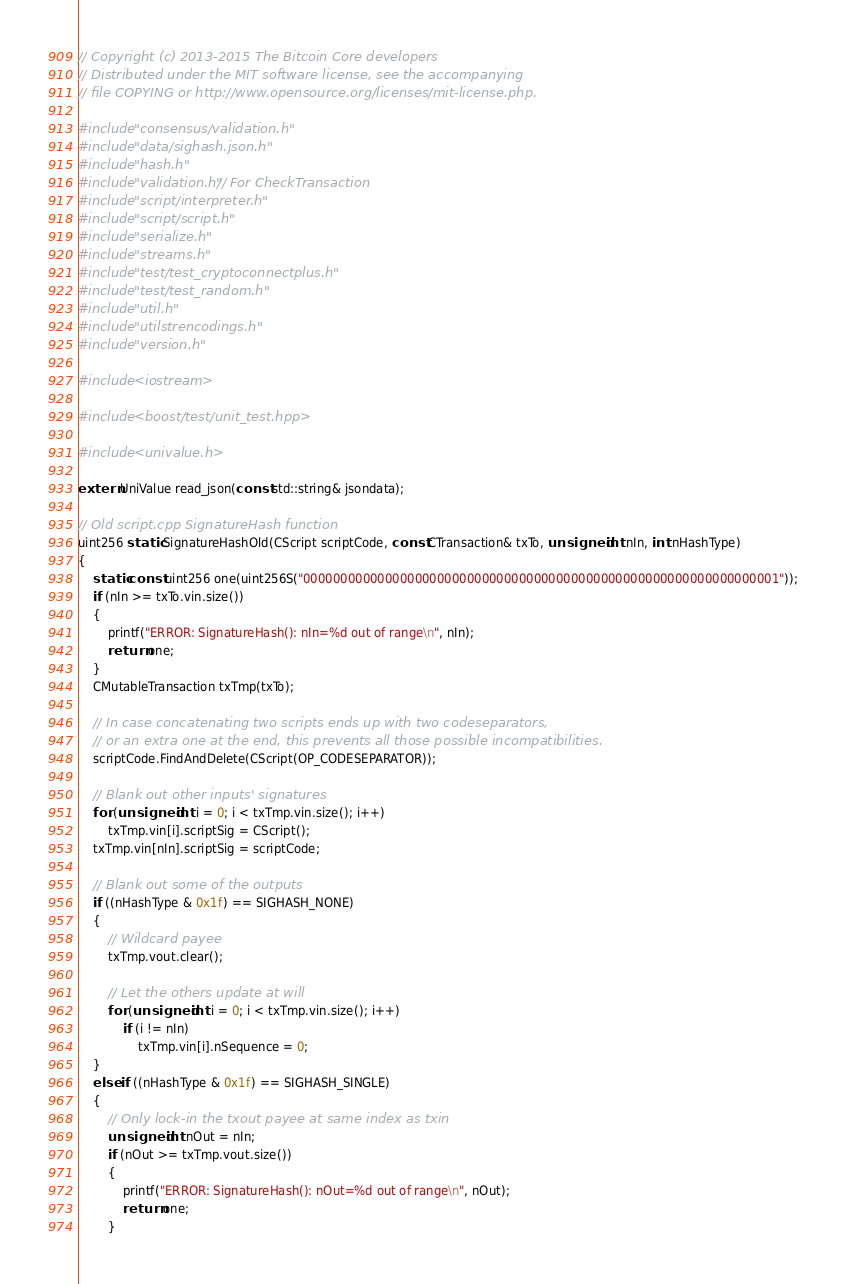Convert code to text. <code><loc_0><loc_0><loc_500><loc_500><_C++_>// Copyright (c) 2013-2015 The Bitcoin Core developers
// Distributed under the MIT software license, see the accompanying
// file COPYING or http://www.opensource.org/licenses/mit-license.php.

#include "consensus/validation.h"
#include "data/sighash.json.h"
#include "hash.h"
#include "validation.h" // For CheckTransaction
#include "script/interpreter.h"
#include "script/script.h"
#include "serialize.h"
#include "streams.h"
#include "test/test_cryptoconnectplus.h"
#include "test/test_random.h"
#include "util.h"
#include "utilstrencodings.h"
#include "version.h"

#include <iostream>

#include <boost/test/unit_test.hpp>

#include <univalue.h>

extern UniValue read_json(const std::string& jsondata);

// Old script.cpp SignatureHash function
uint256 static SignatureHashOld(CScript scriptCode, const CTransaction& txTo, unsigned int nIn, int nHashType)
{
    static const uint256 one(uint256S("0000000000000000000000000000000000000000000000000000000000000001"));
    if (nIn >= txTo.vin.size())
    {
        printf("ERROR: SignatureHash(): nIn=%d out of range\n", nIn);
        return one;
    }
    CMutableTransaction txTmp(txTo);

    // In case concatenating two scripts ends up with two codeseparators,
    // or an extra one at the end, this prevents all those possible incompatibilities.
    scriptCode.FindAndDelete(CScript(OP_CODESEPARATOR));

    // Blank out other inputs' signatures
    for (unsigned int i = 0; i < txTmp.vin.size(); i++)
        txTmp.vin[i].scriptSig = CScript();
    txTmp.vin[nIn].scriptSig = scriptCode;

    // Blank out some of the outputs
    if ((nHashType & 0x1f) == SIGHASH_NONE)
    {
        // Wildcard payee
        txTmp.vout.clear();

        // Let the others update at will
        for (unsigned int i = 0; i < txTmp.vin.size(); i++)
            if (i != nIn)
                txTmp.vin[i].nSequence = 0;
    }
    else if ((nHashType & 0x1f) == SIGHASH_SINGLE)
    {
        // Only lock-in the txout payee at same index as txin
        unsigned int nOut = nIn;
        if (nOut >= txTmp.vout.size())
        {
            printf("ERROR: SignatureHash(): nOut=%d out of range\n", nOut);
            return one;
        }</code> 